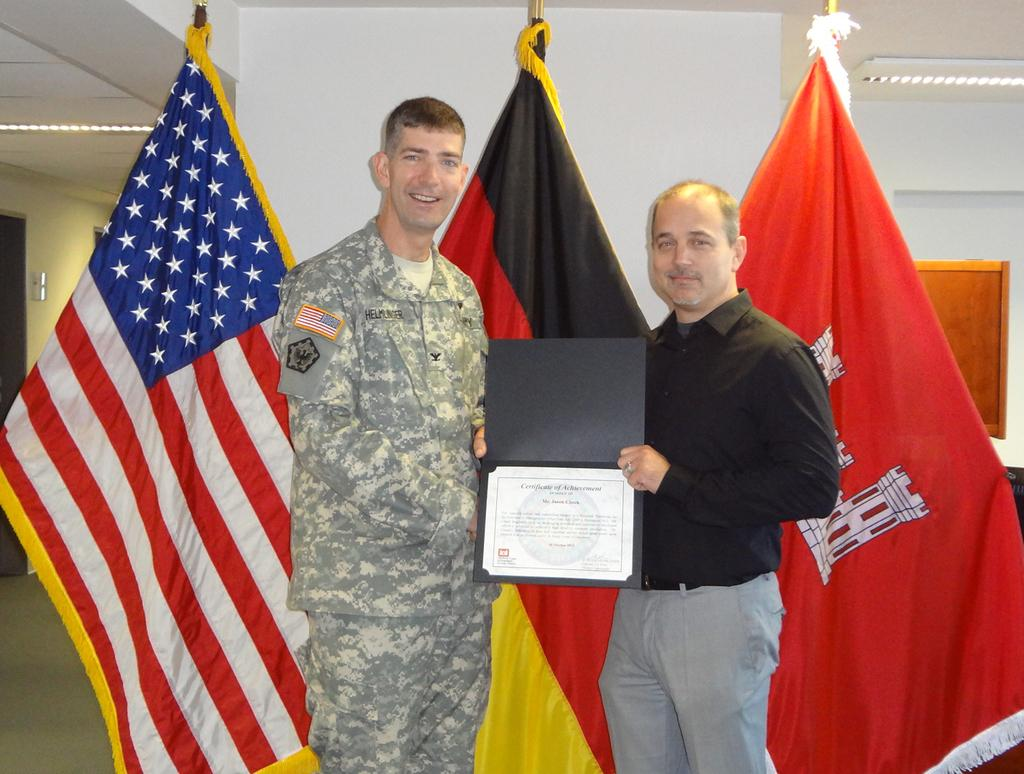<image>
Present a compact description of the photo's key features. A man received a certificate of achievement and poses with flags behind him. 